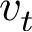<formula> <loc_0><loc_0><loc_500><loc_500>v _ { t }</formula> 